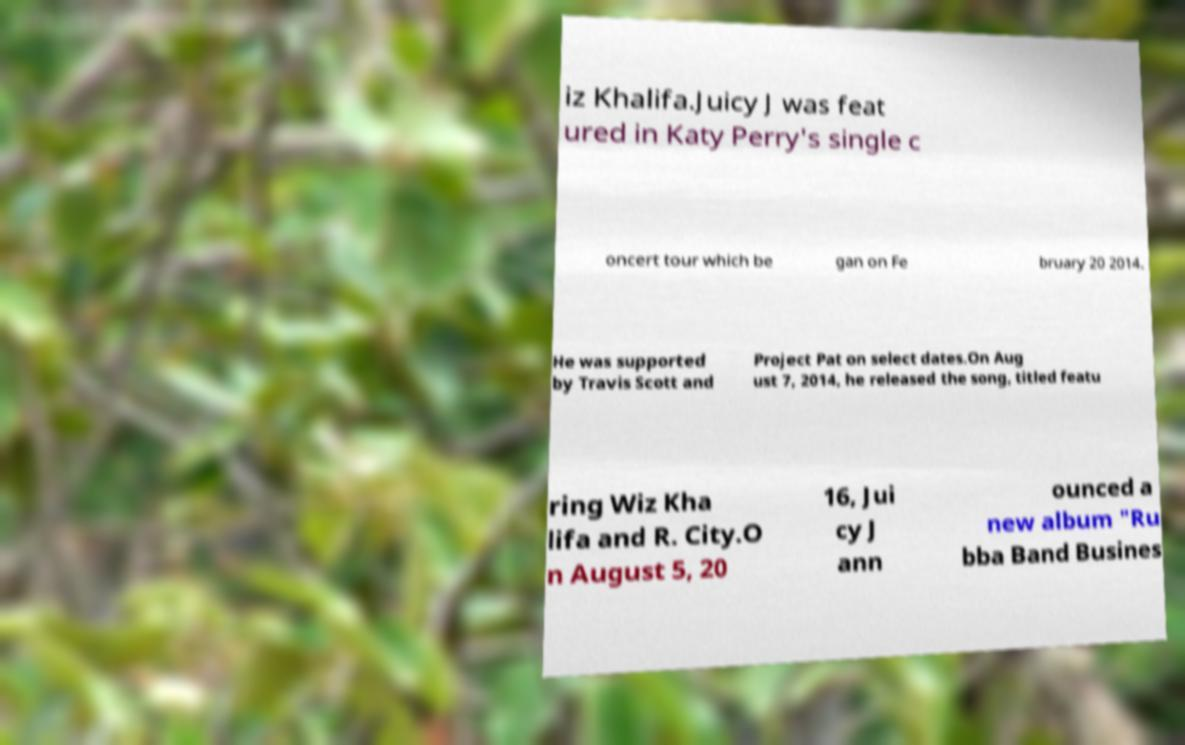Can you read and provide the text displayed in the image?This photo seems to have some interesting text. Can you extract and type it out for me? iz Khalifa.Juicy J was feat ured in Katy Perry's single c oncert tour which be gan on Fe bruary 20 2014. He was supported by Travis Scott and Project Pat on select dates.On Aug ust 7, 2014, he released the song, titled featu ring Wiz Kha lifa and R. City.O n August 5, 20 16, Jui cy J ann ounced a new album "Ru bba Band Busines 